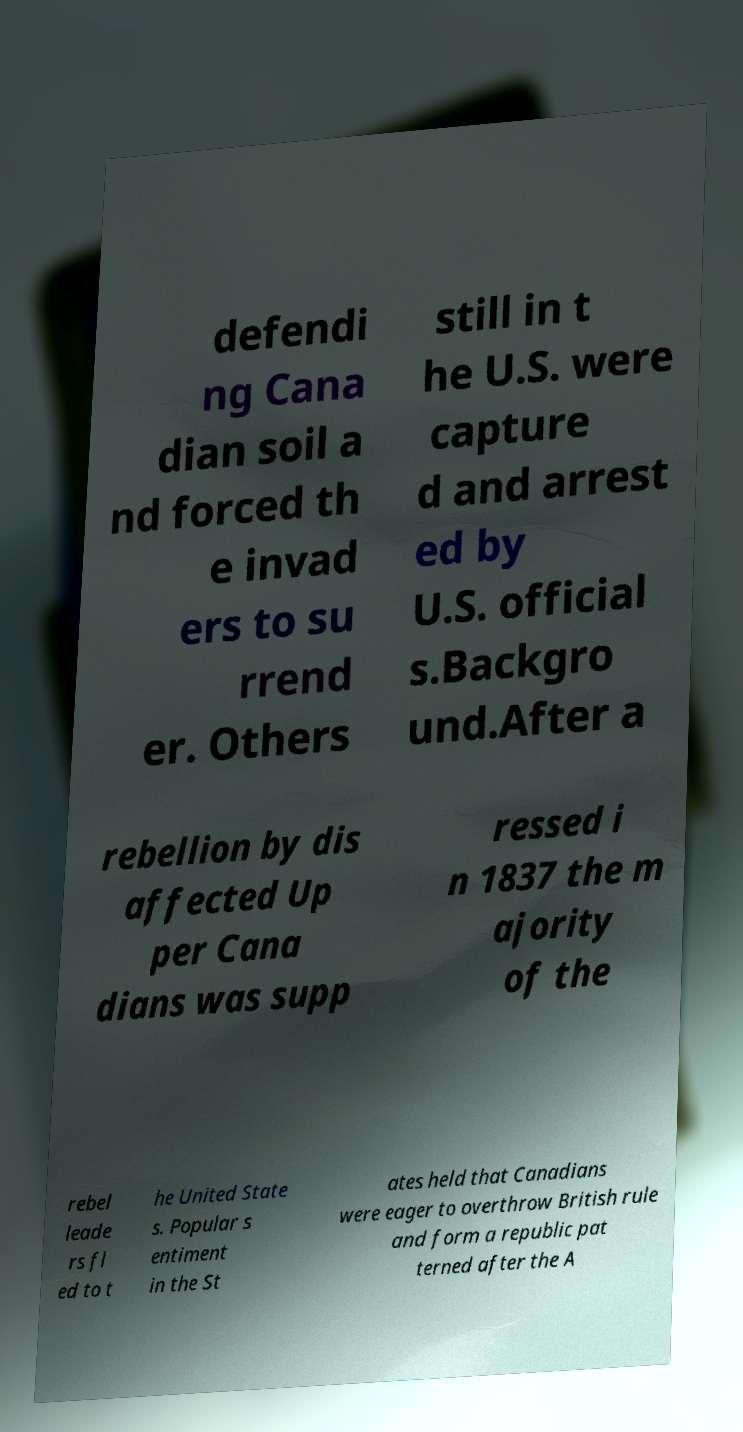Could you assist in decoding the text presented in this image and type it out clearly? defendi ng Cana dian soil a nd forced th e invad ers to su rrend er. Others still in t he U.S. were capture d and arrest ed by U.S. official s.Backgro und.After a rebellion by dis affected Up per Cana dians was supp ressed i n 1837 the m ajority of the rebel leade rs fl ed to t he United State s. Popular s entiment in the St ates held that Canadians were eager to overthrow British rule and form a republic pat terned after the A 